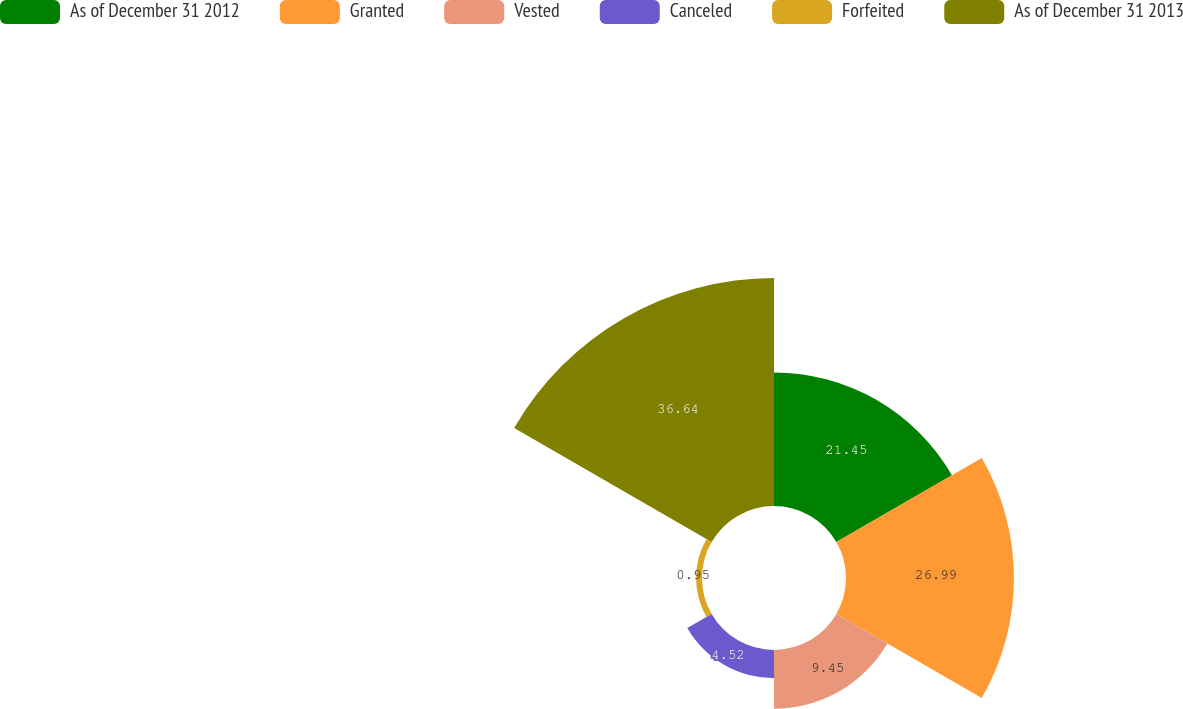Convert chart to OTSL. <chart><loc_0><loc_0><loc_500><loc_500><pie_chart><fcel>As of December 31 2012<fcel>Granted<fcel>Vested<fcel>Canceled<fcel>Forfeited<fcel>As of December 31 2013<nl><fcel>21.45%<fcel>26.99%<fcel>9.45%<fcel>4.52%<fcel>0.95%<fcel>36.64%<nl></chart> 